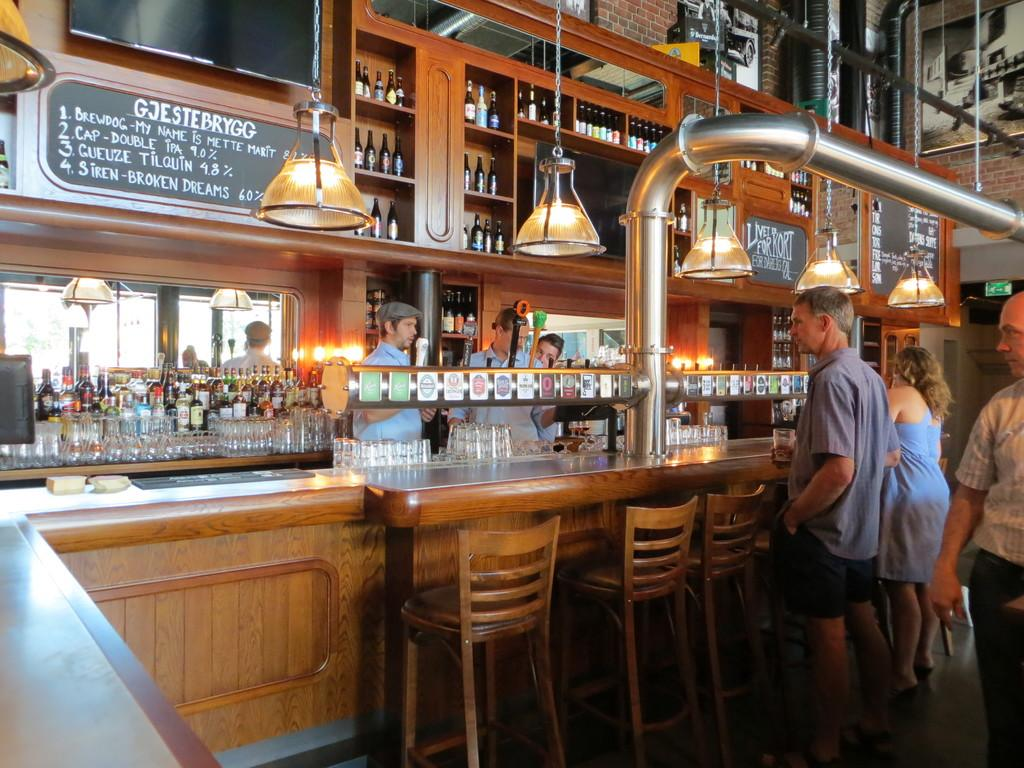What type of view is shown in the image? The image is an inside view. What can be seen inside the cupboards in the image? There are bottles in the cupboards. What can be seen providing illumination in the image? There are lights visible. What type of surface is present in the image? There are boards present. What are the people in the image doing? There are persons standing in front of a table. What type of furniture is present in the image? There is a table and chairs in the image. What grade is the person in the image teaching? There is no indication of a person teaching in the image, nor is there any reference to a grade. 